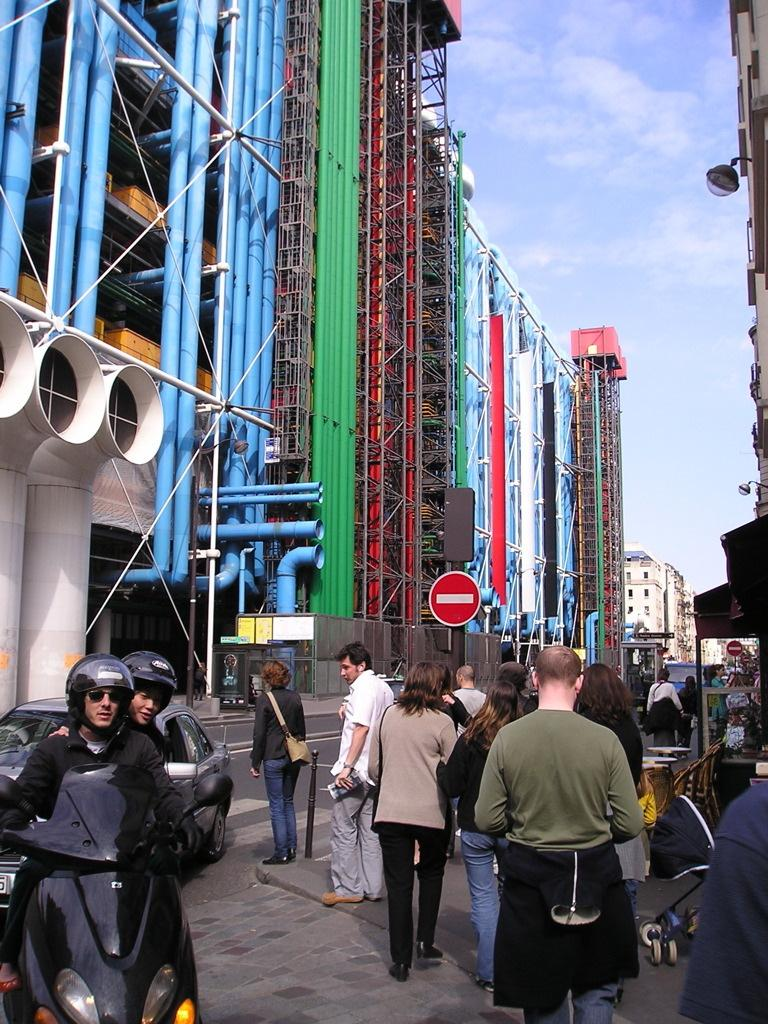What are the people in the image doing? The people in the image are standing on a road. What else can be seen in the image besides the people? There are cars visible in the image. What is visible in the background of the image? There are buildings and the sky visible in the background of the image. Can you see any ants carrying a bun on the chin of one of the people in the image? There are no ants or buns present in the image, and no one's chin is visible in the image. 